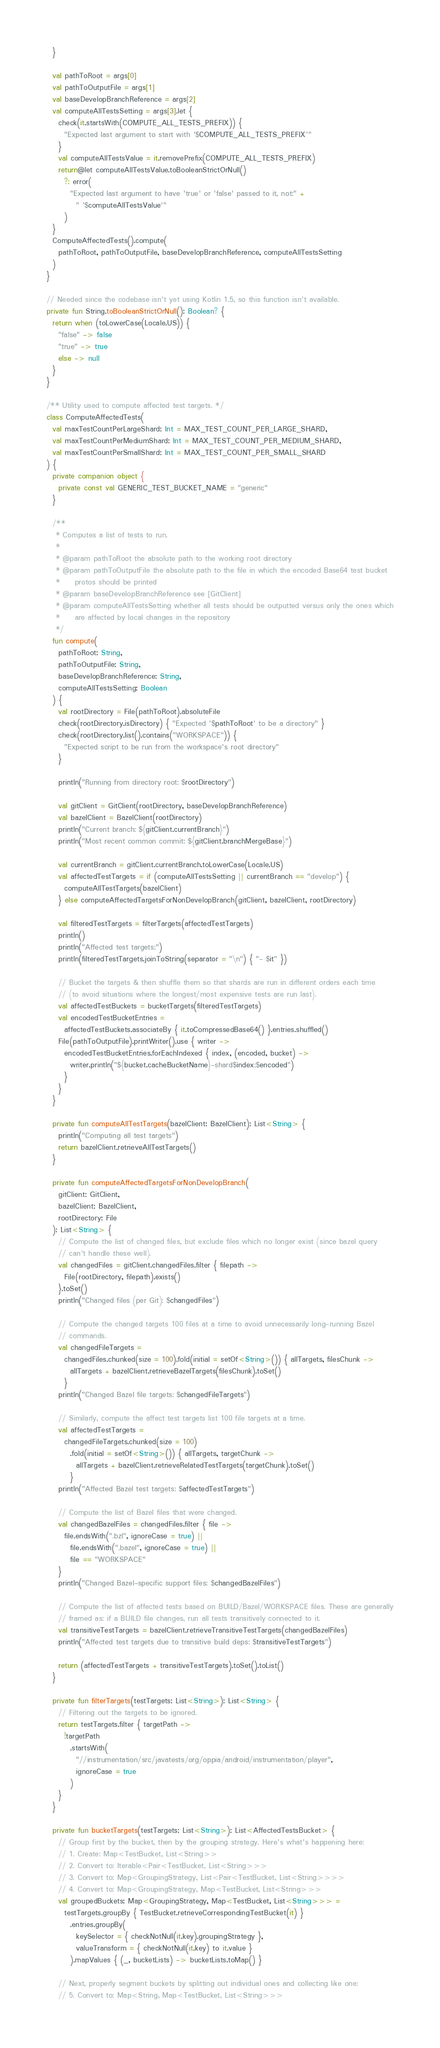<code> <loc_0><loc_0><loc_500><loc_500><_Kotlin_>  }

  val pathToRoot = args[0]
  val pathToOutputFile = args[1]
  val baseDevelopBranchReference = args[2]
  val computeAllTestsSetting = args[3].let {
    check(it.startsWith(COMPUTE_ALL_TESTS_PREFIX)) {
      "Expected last argument to start with '$COMPUTE_ALL_TESTS_PREFIX'"
    }
    val computeAllTestsValue = it.removePrefix(COMPUTE_ALL_TESTS_PREFIX)
    return@let computeAllTestsValue.toBooleanStrictOrNull()
      ?: error(
        "Expected last argument to have 'true' or 'false' passed to it, not:" +
          " '$computeAllTestsValue'"
      )
  }
  ComputeAffectedTests().compute(
    pathToRoot, pathToOutputFile, baseDevelopBranchReference, computeAllTestsSetting
  )
}

// Needed since the codebase isn't yet using Kotlin 1.5, so this function isn't available.
private fun String.toBooleanStrictOrNull(): Boolean? {
  return when (toLowerCase(Locale.US)) {
    "false" -> false
    "true" -> true
    else -> null
  }
}

/** Utility used to compute affected test targets. */
class ComputeAffectedTests(
  val maxTestCountPerLargeShard: Int = MAX_TEST_COUNT_PER_LARGE_SHARD,
  val maxTestCountPerMediumShard: Int = MAX_TEST_COUNT_PER_MEDIUM_SHARD,
  val maxTestCountPerSmallShard: Int = MAX_TEST_COUNT_PER_SMALL_SHARD
) {
  private companion object {
    private const val GENERIC_TEST_BUCKET_NAME = "generic"
  }

  /**
   * Computes a list of tests to run.
   *
   * @param pathToRoot the absolute path to the working root directory
   * @param pathToOutputFile the absolute path to the file in which the encoded Base64 test bucket
   *     protos should be printed
   * @param baseDevelopBranchReference see [GitClient]
   * @param computeAllTestsSetting whether all tests should be outputted versus only the ones which
   *     are affected by local changes in the repository
   */
  fun compute(
    pathToRoot: String,
    pathToOutputFile: String,
    baseDevelopBranchReference: String,
    computeAllTestsSetting: Boolean
  ) {
    val rootDirectory = File(pathToRoot).absoluteFile
    check(rootDirectory.isDirectory) { "Expected '$pathToRoot' to be a directory" }
    check(rootDirectory.list().contains("WORKSPACE")) {
      "Expected script to be run from the workspace's root directory"
    }

    println("Running from directory root: $rootDirectory")

    val gitClient = GitClient(rootDirectory, baseDevelopBranchReference)
    val bazelClient = BazelClient(rootDirectory)
    println("Current branch: ${gitClient.currentBranch}")
    println("Most recent common commit: ${gitClient.branchMergeBase}")

    val currentBranch = gitClient.currentBranch.toLowerCase(Locale.US)
    val affectedTestTargets = if (computeAllTestsSetting || currentBranch == "develop") {
      computeAllTestTargets(bazelClient)
    } else computeAffectedTargetsForNonDevelopBranch(gitClient, bazelClient, rootDirectory)

    val filteredTestTargets = filterTargets(affectedTestTargets)
    println()
    println("Affected test targets:")
    println(filteredTestTargets.joinToString(separator = "\n") { "- $it" })

    // Bucket the targets & then shuffle them so that shards are run in different orders each time
    // (to avoid situations where the longest/most expensive tests are run last).
    val affectedTestBuckets = bucketTargets(filteredTestTargets)
    val encodedTestBucketEntries =
      affectedTestBuckets.associateBy { it.toCompressedBase64() }.entries.shuffled()
    File(pathToOutputFile).printWriter().use { writer ->
      encodedTestBucketEntries.forEachIndexed { index, (encoded, bucket) ->
        writer.println("${bucket.cacheBucketName}-shard$index;$encoded")
      }
    }
  }

  private fun computeAllTestTargets(bazelClient: BazelClient): List<String> {
    println("Computing all test targets")
    return bazelClient.retrieveAllTestTargets()
  }

  private fun computeAffectedTargetsForNonDevelopBranch(
    gitClient: GitClient,
    bazelClient: BazelClient,
    rootDirectory: File
  ): List<String> {
    // Compute the list of changed files, but exclude files which no longer exist (since bazel query
    // can't handle these well).
    val changedFiles = gitClient.changedFiles.filter { filepath ->
      File(rootDirectory, filepath).exists()
    }.toSet()
    println("Changed files (per Git): $changedFiles")

    // Compute the changed targets 100 files at a time to avoid unnecessarily long-running Bazel
    // commands.
    val changedFileTargets =
      changedFiles.chunked(size = 100).fold(initial = setOf<String>()) { allTargets, filesChunk ->
        allTargets + bazelClient.retrieveBazelTargets(filesChunk).toSet()
      }
    println("Changed Bazel file targets: $changedFileTargets")

    // Similarly, compute the affect test targets list 100 file targets at a time.
    val affectedTestTargets =
      changedFileTargets.chunked(size = 100)
        .fold(initial = setOf<String>()) { allTargets, targetChunk ->
          allTargets + bazelClient.retrieveRelatedTestTargets(targetChunk).toSet()
        }
    println("Affected Bazel test targets: $affectedTestTargets")

    // Compute the list of Bazel files that were changed.
    val changedBazelFiles = changedFiles.filter { file ->
      file.endsWith(".bzl", ignoreCase = true) ||
        file.endsWith(".bazel", ignoreCase = true) ||
        file == "WORKSPACE"
    }
    println("Changed Bazel-specific support files: $changedBazelFiles")

    // Compute the list of affected tests based on BUILD/Bazel/WORKSPACE files. These are generally
    // framed as: if a BUILD file changes, run all tests transitively connected to it.
    val transitiveTestTargets = bazelClient.retrieveTransitiveTestTargets(changedBazelFiles)
    println("Affected test targets due to transitive build deps: $transitiveTestTargets")

    return (affectedTestTargets + transitiveTestTargets).toSet().toList()
  }

  private fun filterTargets(testTargets: List<String>): List<String> {
    // Filtering out the targets to be ignored.
    return testTargets.filter { targetPath ->
      !targetPath
        .startsWith(
          "//instrumentation/src/javatests/org/oppia/android/instrumentation/player",
          ignoreCase = true
        )
    }
  }

  private fun bucketTargets(testTargets: List<String>): List<AffectedTestsBucket> {
    // Group first by the bucket, then by the grouping strategy. Here's what's happening here:
    // 1. Create: Map<TestBucket, List<String>>
    // 2. Convert to: Iterable<Pair<TestBucket, List<String>>>
    // 3. Convert to: Map<GroupingStrategy, List<Pair<TestBucket, List<String>>>>
    // 4. Convert to: Map<GroupingStrategy, Map<TestBucket, List<String>>>
    val groupedBuckets: Map<GroupingStrategy, Map<TestBucket, List<String>>> =
      testTargets.groupBy { TestBucket.retrieveCorrespondingTestBucket(it) }
        .entries.groupBy(
          keySelector = { checkNotNull(it.key).groupingStrategy },
          valueTransform = { checkNotNull(it.key) to it.value }
        ).mapValues { (_, bucketLists) -> bucketLists.toMap() }

    // Next, properly segment buckets by splitting out individual ones and collecting like one:
    // 5. Convert to: Map<String, Map<TestBucket, List<String>>></code> 